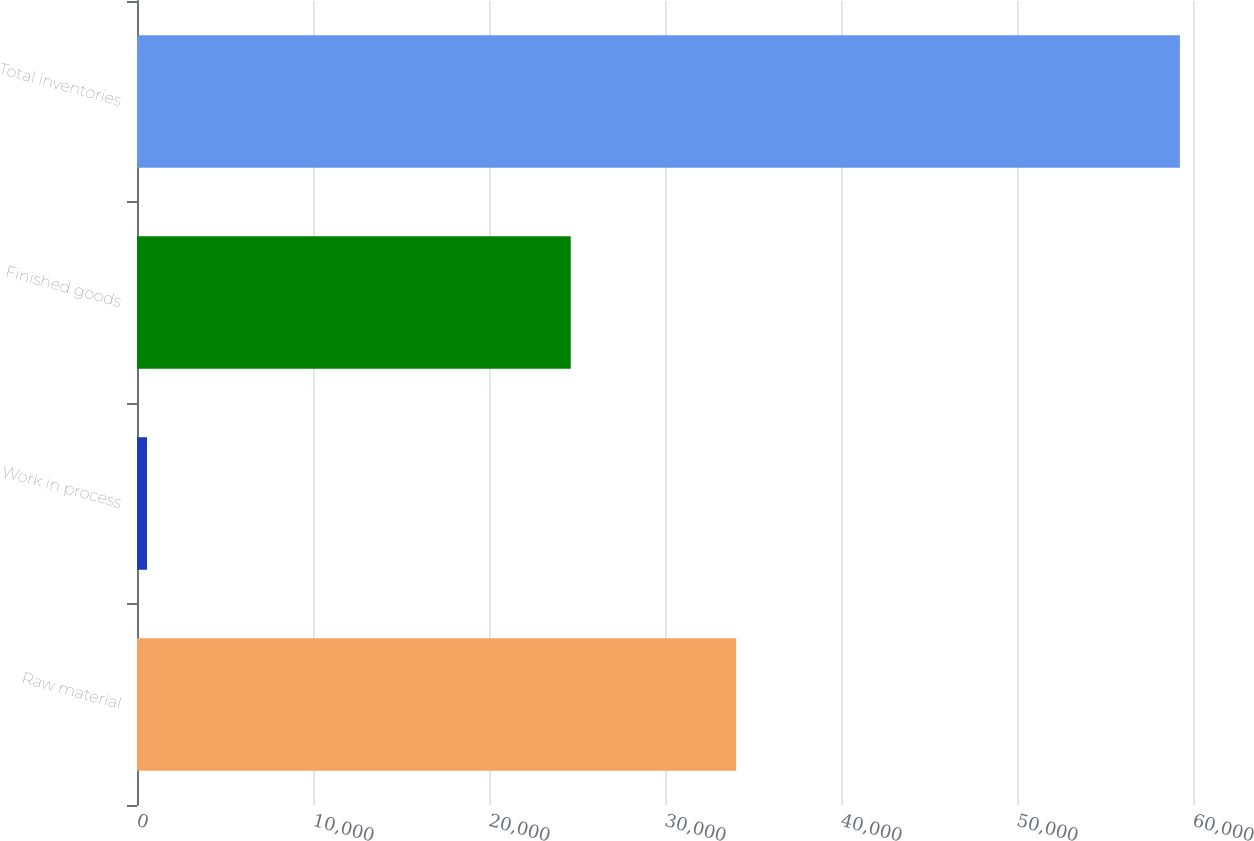<chart> <loc_0><loc_0><loc_500><loc_500><bar_chart><fcel>Raw material<fcel>Work in process<fcel>Finished goods<fcel>Total inventories<nl><fcel>34041<fcel>569<fcel>24645<fcel>59255<nl></chart> 